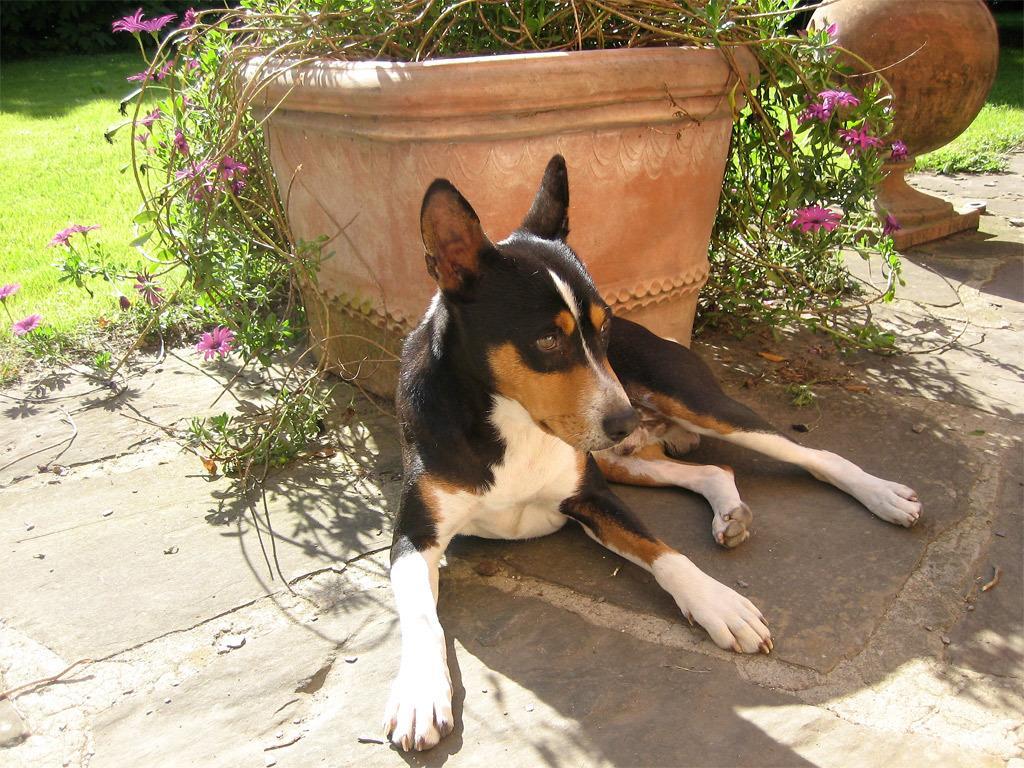Can you describe this image briefly? In this image we can see a dog sitting in front of a flower pot, behind it there is a grass and on the top right corner of the image there is a sculpture. 